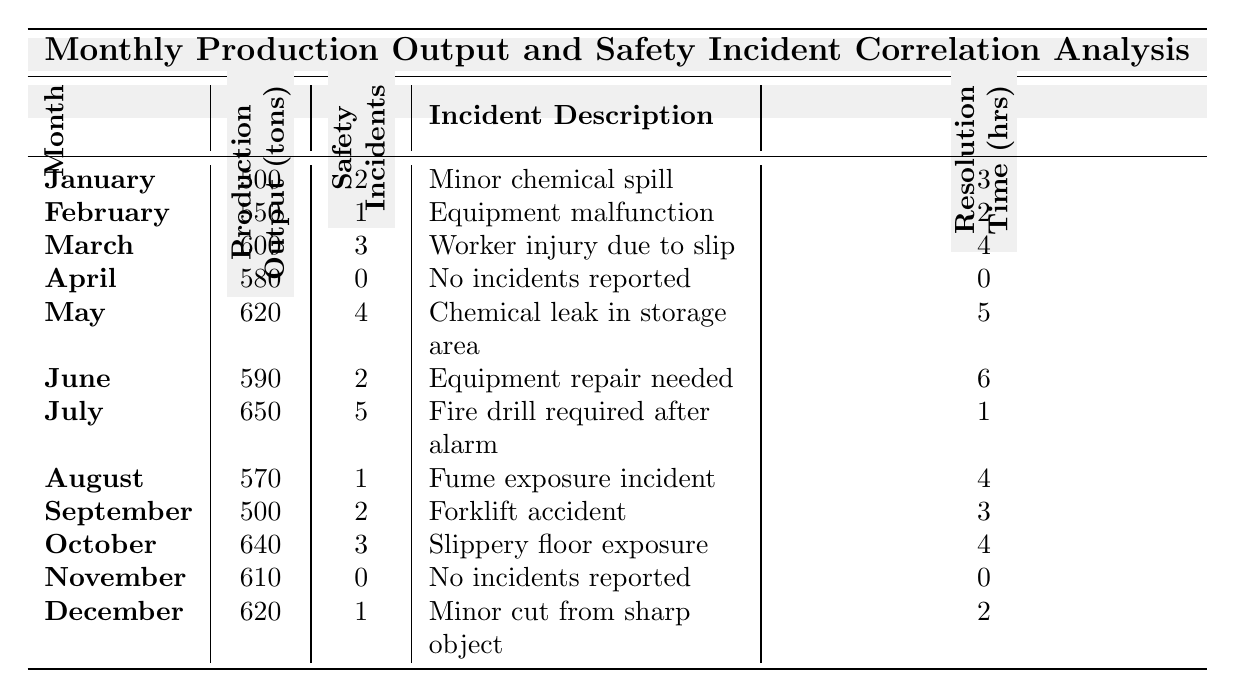What was the total production output for the month of May? From the table, the production output for May is explicitly listed as 620 tons.
Answer: 620 tons How many safety incidents occurred in June? The safety incidents for June are shown directly in the table as 2 incidents.
Answer: 2 incidents What is the incident resolution time for the month with the highest production output? The month with the highest production output is July at 650 tons. The resolution time for July is listed as 1 hour.
Answer: 1 hour Which month had the most safety incidents, and how many incidents were reported? July had the most safety incidents with 5 incidents reported.
Answer: July, 5 incidents What was the average production output for the first quarter (January to March)? Sum the production outputs for January (500), February (550), and March (600): 500 + 550 + 600 = 1650 tons. Divide by 3 months: 1650 / 3 = 550 tons.
Answer: 550 tons Did any month have zero safety incidents? If so, which months? Yes, the months of April and November reported zero safety incidents, as indicated in the table.
Answer: April and November What was the highest number of safety incidents reported in a single month, and what was the incident description for that month? The highest number of safety incidents reported in a month is 5, which occurred in July. The incident description for that month is "Fire drill required after alarm."
Answer: 5 incidents, Fire drill required after alarm Calculate the total incident resolution time for months that experienced safety incidents. Add resolution times for months with incidents: January (3) + February (2) + March (4) + May (5) + June (6) + July (1) + August (4) + September (3) + October (4) + December (2) = 34 hours.
Answer: 34 hours How many months reported more than 2 safety incidents? The months with more than 2 incidents are March (3), May (4), and July (5), totaling 3 months.
Answer: 3 months Is there a correlation between production output and safety incidents based on the data provided in the table? To analyze, we note that higher productions like July (650 tons) had the most incidents (5), while lower outputs like February (550 tons) had fewer incidents (1). This suggests a possible correlation; however, more robust statistical analysis would be needed to confirm.
Answer: Suggests correlation What was the total number of safety incidents reported throughout the year? Adding all reported incidents: 2 + 1 + 3 + 0 + 4 + 2 + 5 + 1 + 2 + 3 + 0 + 1 = 24 incidents total for the year.
Answer: 24 incidents 